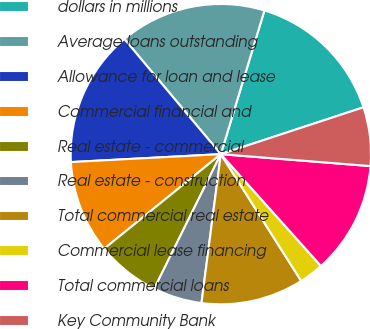<chart> <loc_0><loc_0><loc_500><loc_500><pie_chart><fcel>dollars in millions<fcel>Average loans outstanding<fcel>Allowance for loan and lease<fcel>Commercial financial and<fcel>Real estate - commercial<fcel>Real estate - construction<fcel>Total commercial real estate<fcel>Commercial lease financing<fcel>Total commercial loans<fcel>Key Community Bank<nl><fcel>15.26%<fcel>15.79%<fcel>14.74%<fcel>10.0%<fcel>6.84%<fcel>5.26%<fcel>11.05%<fcel>2.63%<fcel>12.11%<fcel>6.32%<nl></chart> 